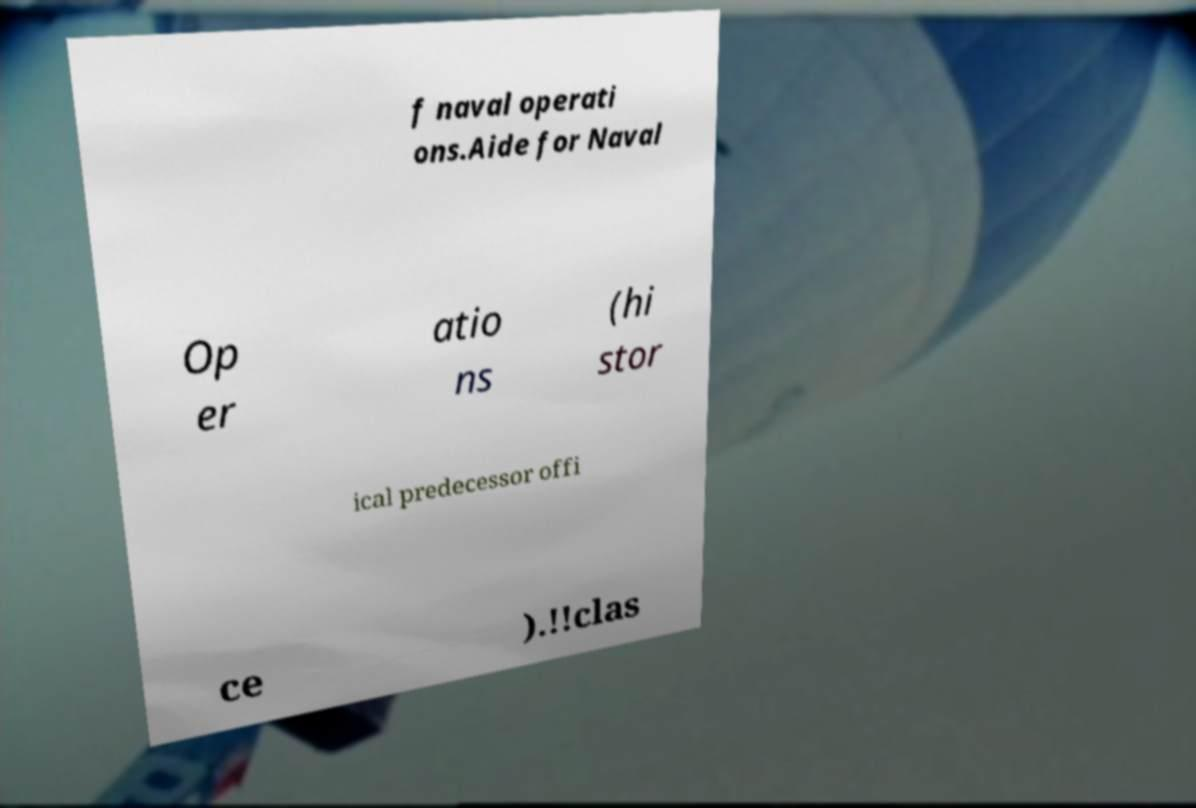What messages or text are displayed in this image? I need them in a readable, typed format. f naval operati ons.Aide for Naval Op er atio ns (hi stor ical predecessor offi ce ).!!clas 